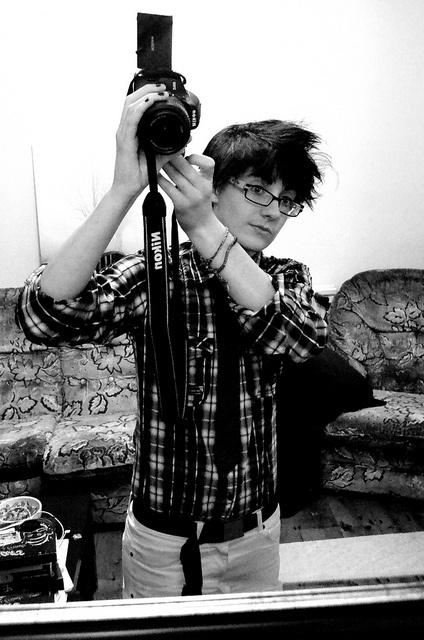Describe the objects in this image and their specific colors. I can see people in white, black, darkgray, gray, and lightgray tones, chair in white, black, gray, darkgray, and lightgray tones, couch in white, black, gray, darkgray, and lightgray tones, couch in white, darkgray, gray, black, and lightgray tones, and tie in black, gray, and white tones in this image. 